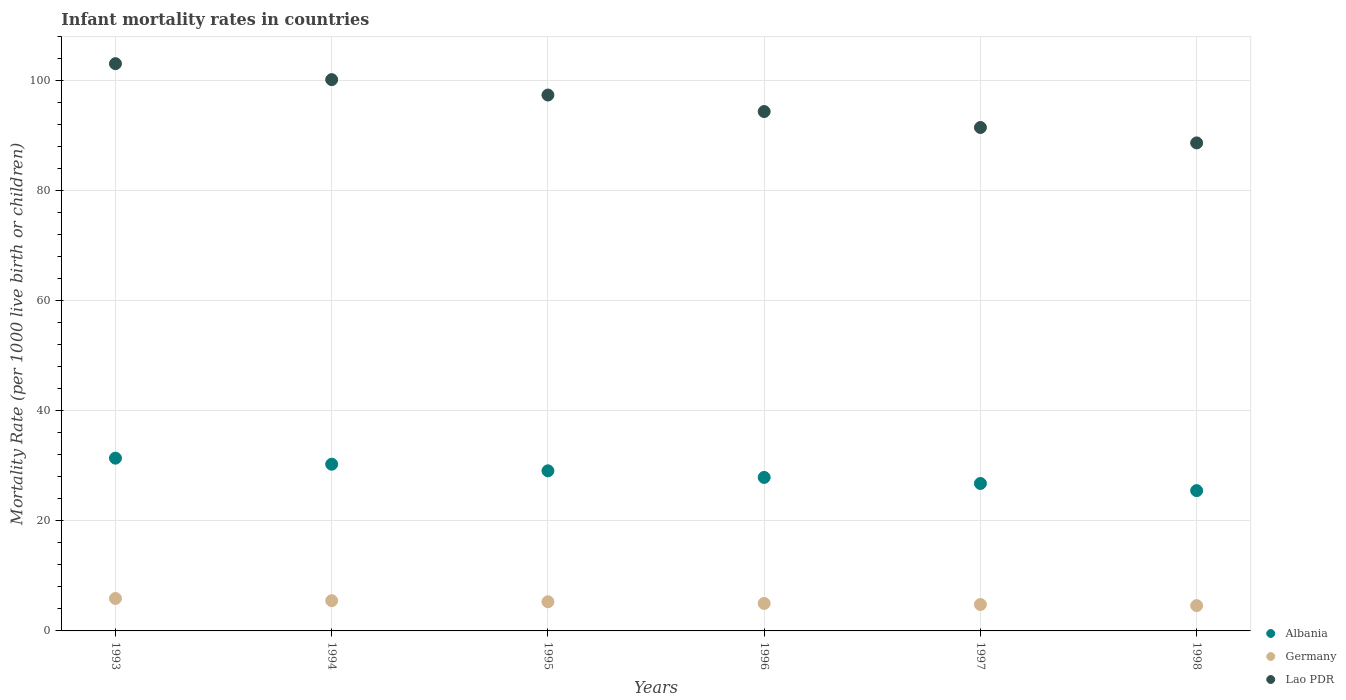How many different coloured dotlines are there?
Give a very brief answer. 3. Is the number of dotlines equal to the number of legend labels?
Provide a short and direct response. Yes. What is the infant mortality rate in Germany in 1994?
Offer a very short reply. 5.5. Across all years, what is the maximum infant mortality rate in Germany?
Keep it short and to the point. 5.9. In which year was the infant mortality rate in Germany maximum?
Your answer should be compact. 1993. In which year was the infant mortality rate in Lao PDR minimum?
Offer a very short reply. 1998. What is the total infant mortality rate in Germany in the graph?
Your answer should be compact. 31.1. What is the difference between the infant mortality rate in Germany in 1994 and the infant mortality rate in Lao PDR in 1996?
Keep it short and to the point. -88.9. What is the average infant mortality rate in Albania per year?
Provide a succinct answer. 28.5. In the year 1993, what is the difference between the infant mortality rate in Lao PDR and infant mortality rate in Germany?
Give a very brief answer. 97.2. What is the ratio of the infant mortality rate in Germany in 1997 to that in 1998?
Offer a very short reply. 1.04. What is the difference between the highest and the second highest infant mortality rate in Lao PDR?
Provide a succinct answer. 2.9. What is the difference between the highest and the lowest infant mortality rate in Germany?
Provide a succinct answer. 1.3. Is it the case that in every year, the sum of the infant mortality rate in Albania and infant mortality rate in Germany  is greater than the infant mortality rate in Lao PDR?
Your response must be concise. No. What is the difference between two consecutive major ticks on the Y-axis?
Make the answer very short. 20. Does the graph contain any zero values?
Offer a very short reply. No. Does the graph contain grids?
Your answer should be compact. Yes. Where does the legend appear in the graph?
Offer a very short reply. Bottom right. What is the title of the graph?
Make the answer very short. Infant mortality rates in countries. Does "Seychelles" appear as one of the legend labels in the graph?
Your answer should be compact. No. What is the label or title of the Y-axis?
Offer a terse response. Mortality Rate (per 1000 live birth or children). What is the Mortality Rate (per 1000 live birth or children) of Albania in 1993?
Offer a terse response. 31.4. What is the Mortality Rate (per 1000 live birth or children) in Germany in 1993?
Your answer should be very brief. 5.9. What is the Mortality Rate (per 1000 live birth or children) in Lao PDR in 1993?
Provide a succinct answer. 103.1. What is the Mortality Rate (per 1000 live birth or children) of Albania in 1994?
Provide a short and direct response. 30.3. What is the Mortality Rate (per 1000 live birth or children) in Germany in 1994?
Your response must be concise. 5.5. What is the Mortality Rate (per 1000 live birth or children) of Lao PDR in 1994?
Provide a succinct answer. 100.2. What is the Mortality Rate (per 1000 live birth or children) of Albania in 1995?
Offer a terse response. 29.1. What is the Mortality Rate (per 1000 live birth or children) in Lao PDR in 1995?
Provide a short and direct response. 97.4. What is the Mortality Rate (per 1000 live birth or children) in Albania in 1996?
Provide a succinct answer. 27.9. What is the Mortality Rate (per 1000 live birth or children) in Germany in 1996?
Your response must be concise. 5. What is the Mortality Rate (per 1000 live birth or children) of Lao PDR in 1996?
Provide a succinct answer. 94.4. What is the Mortality Rate (per 1000 live birth or children) in Albania in 1997?
Your answer should be very brief. 26.8. What is the Mortality Rate (per 1000 live birth or children) in Lao PDR in 1997?
Give a very brief answer. 91.5. What is the Mortality Rate (per 1000 live birth or children) in Lao PDR in 1998?
Provide a short and direct response. 88.7. Across all years, what is the maximum Mortality Rate (per 1000 live birth or children) in Albania?
Provide a succinct answer. 31.4. Across all years, what is the maximum Mortality Rate (per 1000 live birth or children) of Germany?
Provide a succinct answer. 5.9. Across all years, what is the maximum Mortality Rate (per 1000 live birth or children) in Lao PDR?
Provide a short and direct response. 103.1. Across all years, what is the minimum Mortality Rate (per 1000 live birth or children) of Albania?
Make the answer very short. 25.5. Across all years, what is the minimum Mortality Rate (per 1000 live birth or children) of Germany?
Your response must be concise. 4.6. Across all years, what is the minimum Mortality Rate (per 1000 live birth or children) of Lao PDR?
Keep it short and to the point. 88.7. What is the total Mortality Rate (per 1000 live birth or children) of Albania in the graph?
Provide a succinct answer. 171. What is the total Mortality Rate (per 1000 live birth or children) of Germany in the graph?
Your answer should be very brief. 31.1. What is the total Mortality Rate (per 1000 live birth or children) of Lao PDR in the graph?
Your answer should be compact. 575.3. What is the difference between the Mortality Rate (per 1000 live birth or children) in Albania in 1993 and that in 1994?
Make the answer very short. 1.1. What is the difference between the Mortality Rate (per 1000 live birth or children) of Germany in 1993 and that in 1994?
Your answer should be compact. 0.4. What is the difference between the Mortality Rate (per 1000 live birth or children) of Lao PDR in 1993 and that in 1994?
Offer a terse response. 2.9. What is the difference between the Mortality Rate (per 1000 live birth or children) of Albania in 1993 and that in 1995?
Offer a terse response. 2.3. What is the difference between the Mortality Rate (per 1000 live birth or children) in Albania in 1993 and that in 1996?
Your response must be concise. 3.5. What is the difference between the Mortality Rate (per 1000 live birth or children) of Germany in 1993 and that in 1996?
Your response must be concise. 0.9. What is the difference between the Mortality Rate (per 1000 live birth or children) in Lao PDR in 1993 and that in 1996?
Your response must be concise. 8.7. What is the difference between the Mortality Rate (per 1000 live birth or children) of Albania in 1994 and that in 1995?
Ensure brevity in your answer.  1.2. What is the difference between the Mortality Rate (per 1000 live birth or children) of Germany in 1994 and that in 1997?
Provide a short and direct response. 0.7. What is the difference between the Mortality Rate (per 1000 live birth or children) of Lao PDR in 1994 and that in 1997?
Offer a terse response. 8.7. What is the difference between the Mortality Rate (per 1000 live birth or children) of Albania in 1994 and that in 1998?
Offer a very short reply. 4.8. What is the difference between the Mortality Rate (per 1000 live birth or children) in Germany in 1994 and that in 1998?
Keep it short and to the point. 0.9. What is the difference between the Mortality Rate (per 1000 live birth or children) in Lao PDR in 1995 and that in 1996?
Offer a very short reply. 3. What is the difference between the Mortality Rate (per 1000 live birth or children) in Albania in 1995 and that in 1997?
Ensure brevity in your answer.  2.3. What is the difference between the Mortality Rate (per 1000 live birth or children) of Germany in 1995 and that in 1998?
Your answer should be compact. 0.7. What is the difference between the Mortality Rate (per 1000 live birth or children) in Lao PDR in 1995 and that in 1998?
Your response must be concise. 8.7. What is the difference between the Mortality Rate (per 1000 live birth or children) of Germany in 1996 and that in 1997?
Your answer should be very brief. 0.2. What is the difference between the Mortality Rate (per 1000 live birth or children) in Lao PDR in 1996 and that in 1997?
Your answer should be compact. 2.9. What is the difference between the Mortality Rate (per 1000 live birth or children) in Albania in 1996 and that in 1998?
Ensure brevity in your answer.  2.4. What is the difference between the Mortality Rate (per 1000 live birth or children) of Germany in 1996 and that in 1998?
Give a very brief answer. 0.4. What is the difference between the Mortality Rate (per 1000 live birth or children) of Lao PDR in 1996 and that in 1998?
Provide a short and direct response. 5.7. What is the difference between the Mortality Rate (per 1000 live birth or children) in Albania in 1997 and that in 1998?
Keep it short and to the point. 1.3. What is the difference between the Mortality Rate (per 1000 live birth or children) in Lao PDR in 1997 and that in 1998?
Offer a terse response. 2.8. What is the difference between the Mortality Rate (per 1000 live birth or children) of Albania in 1993 and the Mortality Rate (per 1000 live birth or children) of Germany in 1994?
Your answer should be compact. 25.9. What is the difference between the Mortality Rate (per 1000 live birth or children) of Albania in 1993 and the Mortality Rate (per 1000 live birth or children) of Lao PDR in 1994?
Make the answer very short. -68.8. What is the difference between the Mortality Rate (per 1000 live birth or children) of Germany in 1993 and the Mortality Rate (per 1000 live birth or children) of Lao PDR in 1994?
Your response must be concise. -94.3. What is the difference between the Mortality Rate (per 1000 live birth or children) of Albania in 1993 and the Mortality Rate (per 1000 live birth or children) of Germany in 1995?
Offer a very short reply. 26.1. What is the difference between the Mortality Rate (per 1000 live birth or children) of Albania in 1993 and the Mortality Rate (per 1000 live birth or children) of Lao PDR in 1995?
Provide a succinct answer. -66. What is the difference between the Mortality Rate (per 1000 live birth or children) in Germany in 1993 and the Mortality Rate (per 1000 live birth or children) in Lao PDR in 1995?
Provide a short and direct response. -91.5. What is the difference between the Mortality Rate (per 1000 live birth or children) in Albania in 1993 and the Mortality Rate (per 1000 live birth or children) in Germany in 1996?
Provide a short and direct response. 26.4. What is the difference between the Mortality Rate (per 1000 live birth or children) of Albania in 1993 and the Mortality Rate (per 1000 live birth or children) of Lao PDR in 1996?
Ensure brevity in your answer.  -63. What is the difference between the Mortality Rate (per 1000 live birth or children) in Germany in 1993 and the Mortality Rate (per 1000 live birth or children) in Lao PDR in 1996?
Offer a very short reply. -88.5. What is the difference between the Mortality Rate (per 1000 live birth or children) of Albania in 1993 and the Mortality Rate (per 1000 live birth or children) of Germany in 1997?
Your answer should be compact. 26.6. What is the difference between the Mortality Rate (per 1000 live birth or children) of Albania in 1993 and the Mortality Rate (per 1000 live birth or children) of Lao PDR in 1997?
Give a very brief answer. -60.1. What is the difference between the Mortality Rate (per 1000 live birth or children) in Germany in 1993 and the Mortality Rate (per 1000 live birth or children) in Lao PDR in 1997?
Ensure brevity in your answer.  -85.6. What is the difference between the Mortality Rate (per 1000 live birth or children) in Albania in 1993 and the Mortality Rate (per 1000 live birth or children) in Germany in 1998?
Your answer should be compact. 26.8. What is the difference between the Mortality Rate (per 1000 live birth or children) of Albania in 1993 and the Mortality Rate (per 1000 live birth or children) of Lao PDR in 1998?
Offer a terse response. -57.3. What is the difference between the Mortality Rate (per 1000 live birth or children) in Germany in 1993 and the Mortality Rate (per 1000 live birth or children) in Lao PDR in 1998?
Provide a short and direct response. -82.8. What is the difference between the Mortality Rate (per 1000 live birth or children) of Albania in 1994 and the Mortality Rate (per 1000 live birth or children) of Lao PDR in 1995?
Your response must be concise. -67.1. What is the difference between the Mortality Rate (per 1000 live birth or children) of Germany in 1994 and the Mortality Rate (per 1000 live birth or children) of Lao PDR in 1995?
Provide a succinct answer. -91.9. What is the difference between the Mortality Rate (per 1000 live birth or children) of Albania in 1994 and the Mortality Rate (per 1000 live birth or children) of Germany in 1996?
Provide a short and direct response. 25.3. What is the difference between the Mortality Rate (per 1000 live birth or children) of Albania in 1994 and the Mortality Rate (per 1000 live birth or children) of Lao PDR in 1996?
Offer a terse response. -64.1. What is the difference between the Mortality Rate (per 1000 live birth or children) in Germany in 1994 and the Mortality Rate (per 1000 live birth or children) in Lao PDR in 1996?
Ensure brevity in your answer.  -88.9. What is the difference between the Mortality Rate (per 1000 live birth or children) in Albania in 1994 and the Mortality Rate (per 1000 live birth or children) in Germany in 1997?
Offer a very short reply. 25.5. What is the difference between the Mortality Rate (per 1000 live birth or children) in Albania in 1994 and the Mortality Rate (per 1000 live birth or children) in Lao PDR in 1997?
Provide a short and direct response. -61.2. What is the difference between the Mortality Rate (per 1000 live birth or children) in Germany in 1994 and the Mortality Rate (per 1000 live birth or children) in Lao PDR in 1997?
Offer a terse response. -86. What is the difference between the Mortality Rate (per 1000 live birth or children) in Albania in 1994 and the Mortality Rate (per 1000 live birth or children) in Germany in 1998?
Your answer should be compact. 25.7. What is the difference between the Mortality Rate (per 1000 live birth or children) of Albania in 1994 and the Mortality Rate (per 1000 live birth or children) of Lao PDR in 1998?
Ensure brevity in your answer.  -58.4. What is the difference between the Mortality Rate (per 1000 live birth or children) in Germany in 1994 and the Mortality Rate (per 1000 live birth or children) in Lao PDR in 1998?
Provide a short and direct response. -83.2. What is the difference between the Mortality Rate (per 1000 live birth or children) of Albania in 1995 and the Mortality Rate (per 1000 live birth or children) of Germany in 1996?
Offer a terse response. 24.1. What is the difference between the Mortality Rate (per 1000 live birth or children) in Albania in 1995 and the Mortality Rate (per 1000 live birth or children) in Lao PDR in 1996?
Give a very brief answer. -65.3. What is the difference between the Mortality Rate (per 1000 live birth or children) in Germany in 1995 and the Mortality Rate (per 1000 live birth or children) in Lao PDR in 1996?
Your answer should be very brief. -89.1. What is the difference between the Mortality Rate (per 1000 live birth or children) in Albania in 1995 and the Mortality Rate (per 1000 live birth or children) in Germany in 1997?
Your answer should be very brief. 24.3. What is the difference between the Mortality Rate (per 1000 live birth or children) of Albania in 1995 and the Mortality Rate (per 1000 live birth or children) of Lao PDR in 1997?
Your answer should be very brief. -62.4. What is the difference between the Mortality Rate (per 1000 live birth or children) in Germany in 1995 and the Mortality Rate (per 1000 live birth or children) in Lao PDR in 1997?
Your answer should be compact. -86.2. What is the difference between the Mortality Rate (per 1000 live birth or children) of Albania in 1995 and the Mortality Rate (per 1000 live birth or children) of Germany in 1998?
Provide a short and direct response. 24.5. What is the difference between the Mortality Rate (per 1000 live birth or children) in Albania in 1995 and the Mortality Rate (per 1000 live birth or children) in Lao PDR in 1998?
Ensure brevity in your answer.  -59.6. What is the difference between the Mortality Rate (per 1000 live birth or children) in Germany in 1995 and the Mortality Rate (per 1000 live birth or children) in Lao PDR in 1998?
Ensure brevity in your answer.  -83.4. What is the difference between the Mortality Rate (per 1000 live birth or children) in Albania in 1996 and the Mortality Rate (per 1000 live birth or children) in Germany in 1997?
Provide a short and direct response. 23.1. What is the difference between the Mortality Rate (per 1000 live birth or children) in Albania in 1996 and the Mortality Rate (per 1000 live birth or children) in Lao PDR in 1997?
Your response must be concise. -63.6. What is the difference between the Mortality Rate (per 1000 live birth or children) of Germany in 1996 and the Mortality Rate (per 1000 live birth or children) of Lao PDR in 1997?
Provide a short and direct response. -86.5. What is the difference between the Mortality Rate (per 1000 live birth or children) of Albania in 1996 and the Mortality Rate (per 1000 live birth or children) of Germany in 1998?
Offer a very short reply. 23.3. What is the difference between the Mortality Rate (per 1000 live birth or children) in Albania in 1996 and the Mortality Rate (per 1000 live birth or children) in Lao PDR in 1998?
Your response must be concise. -60.8. What is the difference between the Mortality Rate (per 1000 live birth or children) in Germany in 1996 and the Mortality Rate (per 1000 live birth or children) in Lao PDR in 1998?
Provide a short and direct response. -83.7. What is the difference between the Mortality Rate (per 1000 live birth or children) of Albania in 1997 and the Mortality Rate (per 1000 live birth or children) of Germany in 1998?
Your answer should be compact. 22.2. What is the difference between the Mortality Rate (per 1000 live birth or children) of Albania in 1997 and the Mortality Rate (per 1000 live birth or children) of Lao PDR in 1998?
Ensure brevity in your answer.  -61.9. What is the difference between the Mortality Rate (per 1000 live birth or children) of Germany in 1997 and the Mortality Rate (per 1000 live birth or children) of Lao PDR in 1998?
Ensure brevity in your answer.  -83.9. What is the average Mortality Rate (per 1000 live birth or children) in Germany per year?
Your response must be concise. 5.18. What is the average Mortality Rate (per 1000 live birth or children) in Lao PDR per year?
Offer a terse response. 95.88. In the year 1993, what is the difference between the Mortality Rate (per 1000 live birth or children) of Albania and Mortality Rate (per 1000 live birth or children) of Germany?
Offer a terse response. 25.5. In the year 1993, what is the difference between the Mortality Rate (per 1000 live birth or children) in Albania and Mortality Rate (per 1000 live birth or children) in Lao PDR?
Your answer should be very brief. -71.7. In the year 1993, what is the difference between the Mortality Rate (per 1000 live birth or children) in Germany and Mortality Rate (per 1000 live birth or children) in Lao PDR?
Provide a succinct answer. -97.2. In the year 1994, what is the difference between the Mortality Rate (per 1000 live birth or children) of Albania and Mortality Rate (per 1000 live birth or children) of Germany?
Make the answer very short. 24.8. In the year 1994, what is the difference between the Mortality Rate (per 1000 live birth or children) of Albania and Mortality Rate (per 1000 live birth or children) of Lao PDR?
Provide a short and direct response. -69.9. In the year 1994, what is the difference between the Mortality Rate (per 1000 live birth or children) in Germany and Mortality Rate (per 1000 live birth or children) in Lao PDR?
Make the answer very short. -94.7. In the year 1995, what is the difference between the Mortality Rate (per 1000 live birth or children) in Albania and Mortality Rate (per 1000 live birth or children) in Germany?
Make the answer very short. 23.8. In the year 1995, what is the difference between the Mortality Rate (per 1000 live birth or children) in Albania and Mortality Rate (per 1000 live birth or children) in Lao PDR?
Provide a succinct answer. -68.3. In the year 1995, what is the difference between the Mortality Rate (per 1000 live birth or children) in Germany and Mortality Rate (per 1000 live birth or children) in Lao PDR?
Give a very brief answer. -92.1. In the year 1996, what is the difference between the Mortality Rate (per 1000 live birth or children) in Albania and Mortality Rate (per 1000 live birth or children) in Germany?
Ensure brevity in your answer.  22.9. In the year 1996, what is the difference between the Mortality Rate (per 1000 live birth or children) in Albania and Mortality Rate (per 1000 live birth or children) in Lao PDR?
Provide a short and direct response. -66.5. In the year 1996, what is the difference between the Mortality Rate (per 1000 live birth or children) in Germany and Mortality Rate (per 1000 live birth or children) in Lao PDR?
Offer a very short reply. -89.4. In the year 1997, what is the difference between the Mortality Rate (per 1000 live birth or children) of Albania and Mortality Rate (per 1000 live birth or children) of Germany?
Give a very brief answer. 22. In the year 1997, what is the difference between the Mortality Rate (per 1000 live birth or children) of Albania and Mortality Rate (per 1000 live birth or children) of Lao PDR?
Your answer should be very brief. -64.7. In the year 1997, what is the difference between the Mortality Rate (per 1000 live birth or children) in Germany and Mortality Rate (per 1000 live birth or children) in Lao PDR?
Offer a terse response. -86.7. In the year 1998, what is the difference between the Mortality Rate (per 1000 live birth or children) in Albania and Mortality Rate (per 1000 live birth or children) in Germany?
Give a very brief answer. 20.9. In the year 1998, what is the difference between the Mortality Rate (per 1000 live birth or children) of Albania and Mortality Rate (per 1000 live birth or children) of Lao PDR?
Make the answer very short. -63.2. In the year 1998, what is the difference between the Mortality Rate (per 1000 live birth or children) in Germany and Mortality Rate (per 1000 live birth or children) in Lao PDR?
Keep it short and to the point. -84.1. What is the ratio of the Mortality Rate (per 1000 live birth or children) in Albania in 1993 to that in 1994?
Your response must be concise. 1.04. What is the ratio of the Mortality Rate (per 1000 live birth or children) in Germany in 1993 to that in 1994?
Offer a terse response. 1.07. What is the ratio of the Mortality Rate (per 1000 live birth or children) in Lao PDR in 1993 to that in 1994?
Your response must be concise. 1.03. What is the ratio of the Mortality Rate (per 1000 live birth or children) of Albania in 1993 to that in 1995?
Give a very brief answer. 1.08. What is the ratio of the Mortality Rate (per 1000 live birth or children) in Germany in 1993 to that in 1995?
Your response must be concise. 1.11. What is the ratio of the Mortality Rate (per 1000 live birth or children) of Lao PDR in 1993 to that in 1995?
Your response must be concise. 1.06. What is the ratio of the Mortality Rate (per 1000 live birth or children) in Albania in 1993 to that in 1996?
Your response must be concise. 1.13. What is the ratio of the Mortality Rate (per 1000 live birth or children) of Germany in 1993 to that in 1996?
Give a very brief answer. 1.18. What is the ratio of the Mortality Rate (per 1000 live birth or children) of Lao PDR in 1993 to that in 1996?
Provide a short and direct response. 1.09. What is the ratio of the Mortality Rate (per 1000 live birth or children) in Albania in 1993 to that in 1997?
Give a very brief answer. 1.17. What is the ratio of the Mortality Rate (per 1000 live birth or children) in Germany in 1993 to that in 1997?
Ensure brevity in your answer.  1.23. What is the ratio of the Mortality Rate (per 1000 live birth or children) in Lao PDR in 1993 to that in 1997?
Your response must be concise. 1.13. What is the ratio of the Mortality Rate (per 1000 live birth or children) of Albania in 1993 to that in 1998?
Your response must be concise. 1.23. What is the ratio of the Mortality Rate (per 1000 live birth or children) in Germany in 1993 to that in 1998?
Ensure brevity in your answer.  1.28. What is the ratio of the Mortality Rate (per 1000 live birth or children) of Lao PDR in 1993 to that in 1998?
Your answer should be compact. 1.16. What is the ratio of the Mortality Rate (per 1000 live birth or children) of Albania in 1994 to that in 1995?
Give a very brief answer. 1.04. What is the ratio of the Mortality Rate (per 1000 live birth or children) of Germany in 1994 to that in 1995?
Give a very brief answer. 1.04. What is the ratio of the Mortality Rate (per 1000 live birth or children) in Lao PDR in 1994 to that in 1995?
Offer a terse response. 1.03. What is the ratio of the Mortality Rate (per 1000 live birth or children) of Albania in 1994 to that in 1996?
Provide a short and direct response. 1.09. What is the ratio of the Mortality Rate (per 1000 live birth or children) of Lao PDR in 1994 to that in 1996?
Keep it short and to the point. 1.06. What is the ratio of the Mortality Rate (per 1000 live birth or children) of Albania in 1994 to that in 1997?
Provide a succinct answer. 1.13. What is the ratio of the Mortality Rate (per 1000 live birth or children) of Germany in 1994 to that in 1997?
Your answer should be very brief. 1.15. What is the ratio of the Mortality Rate (per 1000 live birth or children) in Lao PDR in 1994 to that in 1997?
Give a very brief answer. 1.1. What is the ratio of the Mortality Rate (per 1000 live birth or children) in Albania in 1994 to that in 1998?
Keep it short and to the point. 1.19. What is the ratio of the Mortality Rate (per 1000 live birth or children) of Germany in 1994 to that in 1998?
Your answer should be compact. 1.2. What is the ratio of the Mortality Rate (per 1000 live birth or children) of Lao PDR in 1994 to that in 1998?
Provide a succinct answer. 1.13. What is the ratio of the Mortality Rate (per 1000 live birth or children) of Albania in 1995 to that in 1996?
Ensure brevity in your answer.  1.04. What is the ratio of the Mortality Rate (per 1000 live birth or children) of Germany in 1995 to that in 1996?
Offer a terse response. 1.06. What is the ratio of the Mortality Rate (per 1000 live birth or children) in Lao PDR in 1995 to that in 1996?
Your answer should be very brief. 1.03. What is the ratio of the Mortality Rate (per 1000 live birth or children) of Albania in 1995 to that in 1997?
Your response must be concise. 1.09. What is the ratio of the Mortality Rate (per 1000 live birth or children) in Germany in 1995 to that in 1997?
Provide a succinct answer. 1.1. What is the ratio of the Mortality Rate (per 1000 live birth or children) in Lao PDR in 1995 to that in 1997?
Your answer should be very brief. 1.06. What is the ratio of the Mortality Rate (per 1000 live birth or children) in Albania in 1995 to that in 1998?
Provide a succinct answer. 1.14. What is the ratio of the Mortality Rate (per 1000 live birth or children) in Germany in 1995 to that in 1998?
Provide a succinct answer. 1.15. What is the ratio of the Mortality Rate (per 1000 live birth or children) of Lao PDR in 1995 to that in 1998?
Provide a succinct answer. 1.1. What is the ratio of the Mortality Rate (per 1000 live birth or children) in Albania in 1996 to that in 1997?
Ensure brevity in your answer.  1.04. What is the ratio of the Mortality Rate (per 1000 live birth or children) in Germany in 1996 to that in 1997?
Your answer should be very brief. 1.04. What is the ratio of the Mortality Rate (per 1000 live birth or children) of Lao PDR in 1996 to that in 1997?
Your answer should be very brief. 1.03. What is the ratio of the Mortality Rate (per 1000 live birth or children) of Albania in 1996 to that in 1998?
Ensure brevity in your answer.  1.09. What is the ratio of the Mortality Rate (per 1000 live birth or children) in Germany in 1996 to that in 1998?
Provide a succinct answer. 1.09. What is the ratio of the Mortality Rate (per 1000 live birth or children) in Lao PDR in 1996 to that in 1998?
Provide a succinct answer. 1.06. What is the ratio of the Mortality Rate (per 1000 live birth or children) of Albania in 1997 to that in 1998?
Your answer should be very brief. 1.05. What is the ratio of the Mortality Rate (per 1000 live birth or children) of Germany in 1997 to that in 1998?
Offer a very short reply. 1.04. What is the ratio of the Mortality Rate (per 1000 live birth or children) in Lao PDR in 1997 to that in 1998?
Your response must be concise. 1.03. What is the difference between the highest and the second highest Mortality Rate (per 1000 live birth or children) in Germany?
Your response must be concise. 0.4. What is the difference between the highest and the lowest Mortality Rate (per 1000 live birth or children) of Albania?
Keep it short and to the point. 5.9. What is the difference between the highest and the lowest Mortality Rate (per 1000 live birth or children) of Germany?
Provide a succinct answer. 1.3. What is the difference between the highest and the lowest Mortality Rate (per 1000 live birth or children) in Lao PDR?
Ensure brevity in your answer.  14.4. 